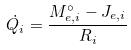Convert formula to latex. <formula><loc_0><loc_0><loc_500><loc_500>\dot { Q _ { i } } = \frac { M _ { e , i } ^ { \circ } - J _ { e , i } } { R _ { i } }</formula> 